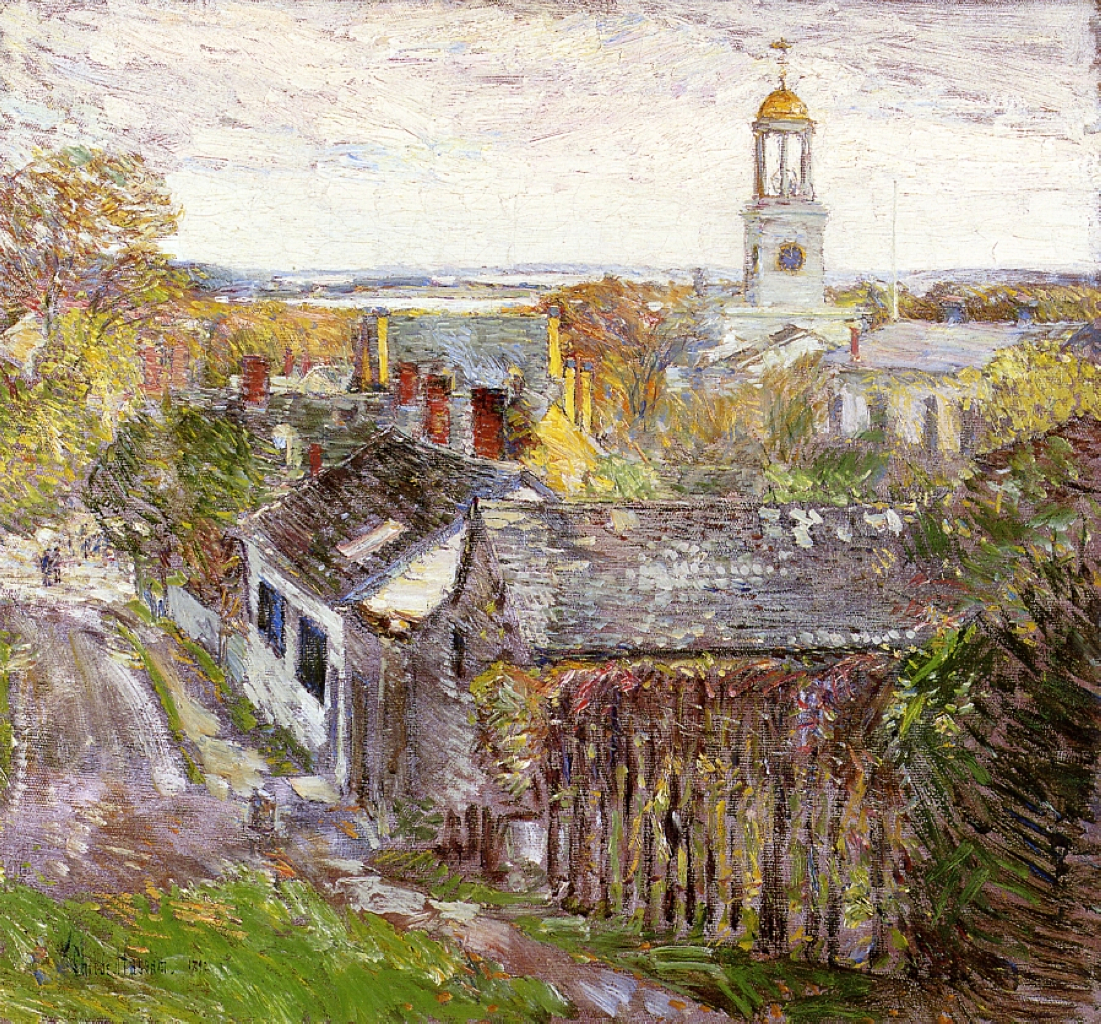How does the artist utilize light in this composition, and what mood does it create? The artist masterfully uses light to infuse life into the scene. The dappling of light and shadow creates a vibrant texture across the landscape, enhancing the rustic charm of the town. The soft illumination of the church dome and the reflective light on the wet cobblestone path suggest a serene, possibly morning setting, evoking a sense of peace and quietude. This strategic play of light not only highlights the architectural and natural elements but also sets a contemplative, almost reverential mood within the painting. 